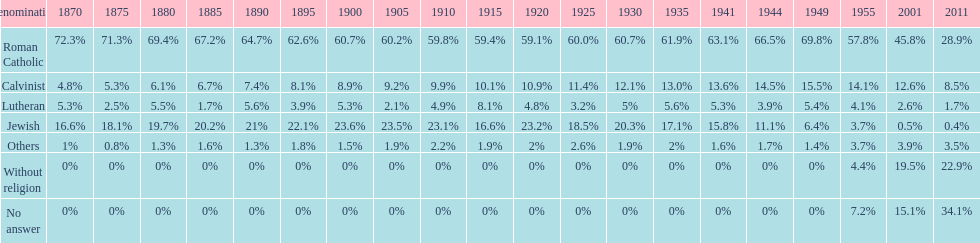Which denomination has the highest margin? Roman Catholic. 